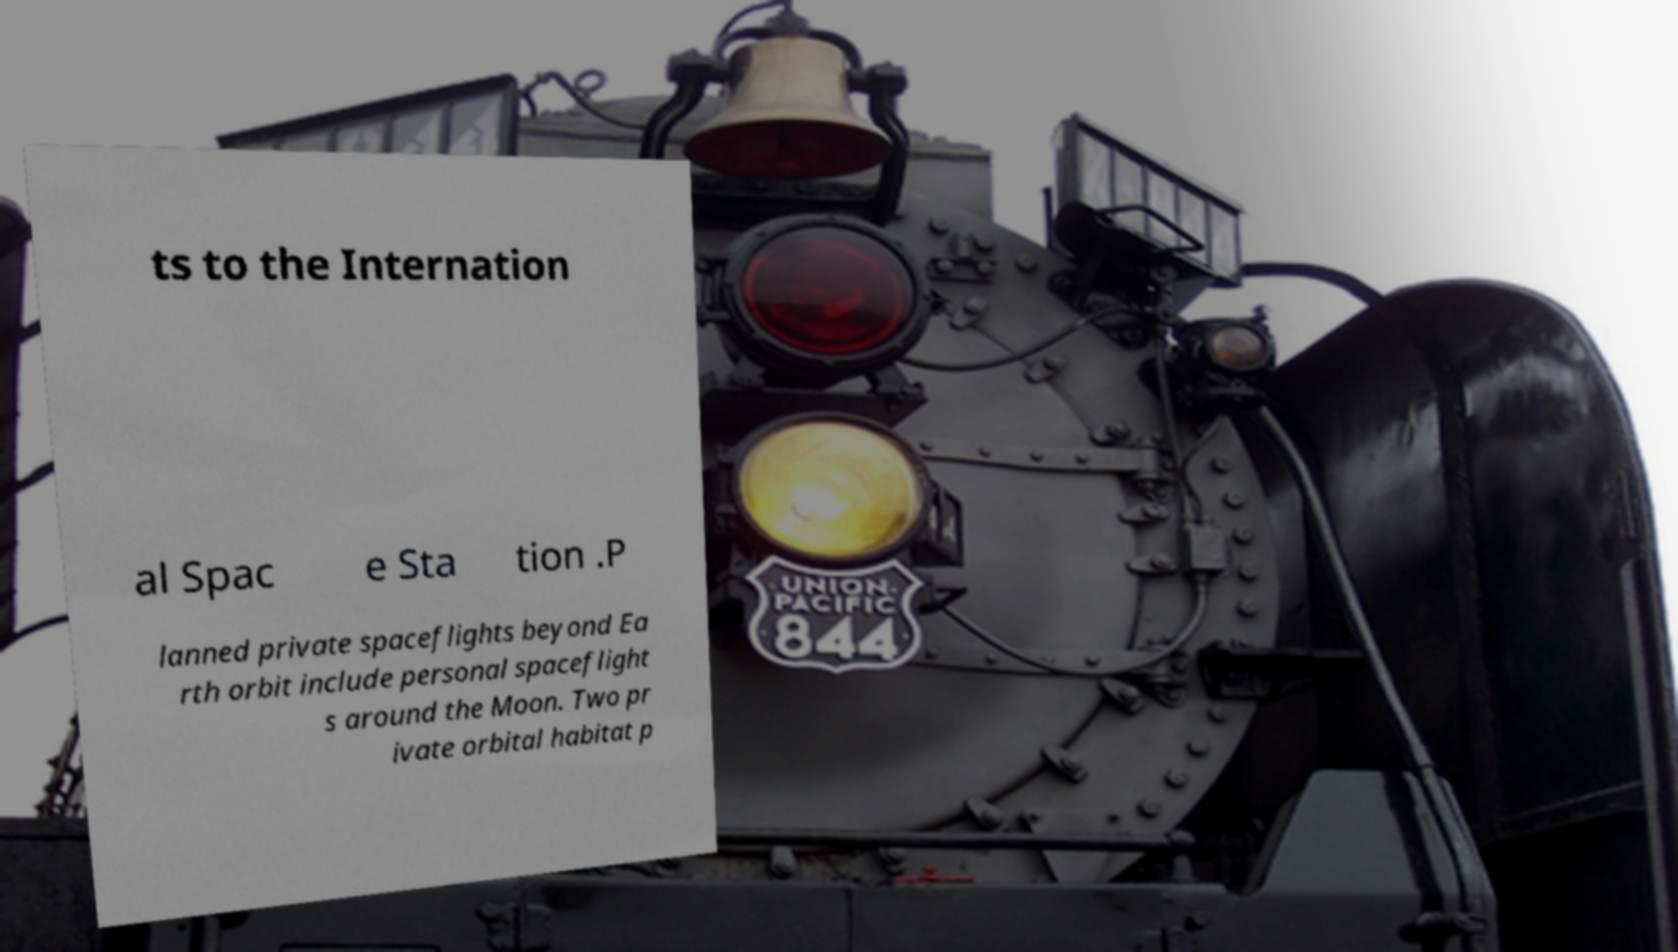Could you assist in decoding the text presented in this image and type it out clearly? ts to the Internation al Spac e Sta tion .P lanned private spaceflights beyond Ea rth orbit include personal spaceflight s around the Moon. Two pr ivate orbital habitat p 